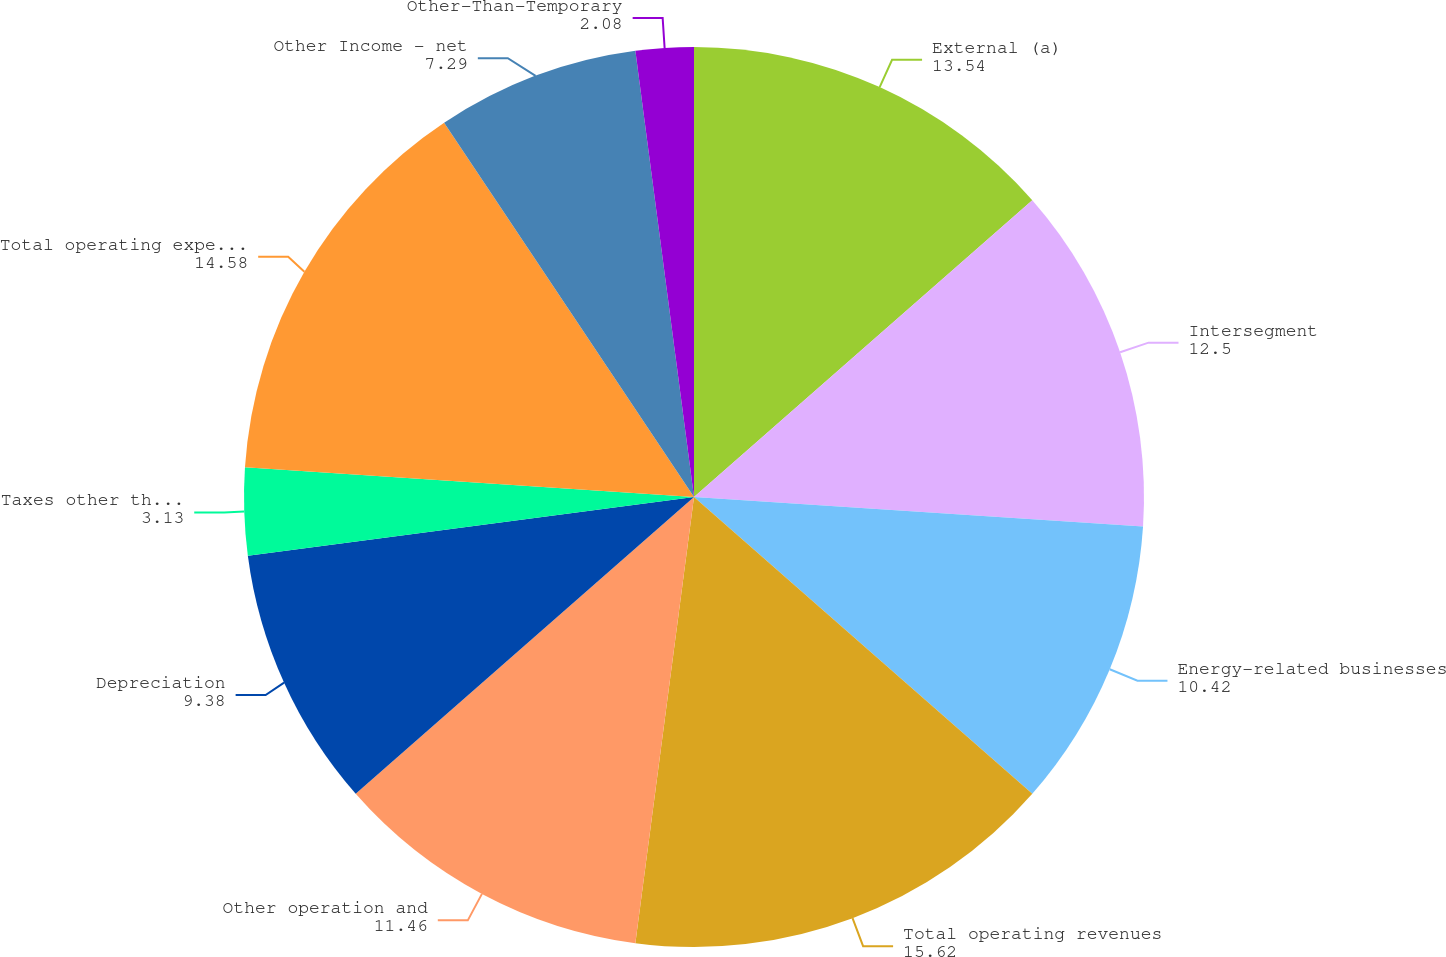<chart> <loc_0><loc_0><loc_500><loc_500><pie_chart><fcel>External (a)<fcel>Intersegment<fcel>Energy-related businesses<fcel>Total operating revenues<fcel>Other operation and<fcel>Depreciation<fcel>Taxes other than income<fcel>Total operating expenses<fcel>Other Income - net<fcel>Other-Than-Temporary<nl><fcel>13.54%<fcel>12.5%<fcel>10.42%<fcel>15.62%<fcel>11.46%<fcel>9.38%<fcel>3.13%<fcel>14.58%<fcel>7.29%<fcel>2.08%<nl></chart> 